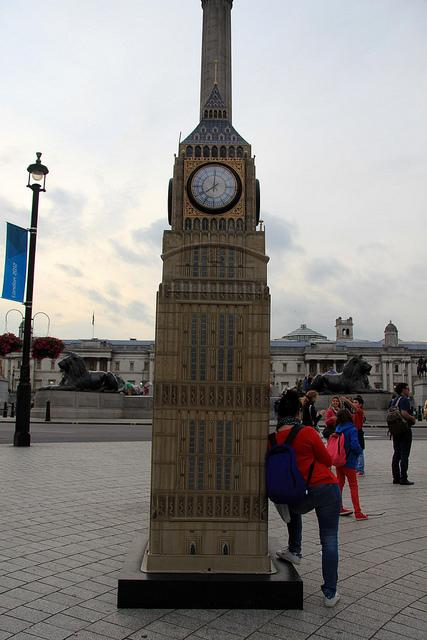What public service does the structure seen here serve? Please explain your reasoning. time keeping. There is a clock near the top of the structure. 